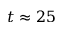Convert formula to latex. <formula><loc_0><loc_0><loc_500><loc_500>t \approx 2 5</formula> 